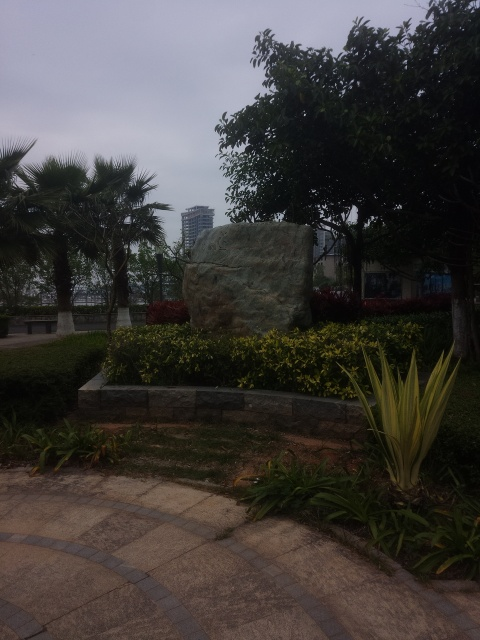What might be the significance of the large rock in this garden setting? The large rock in the garden likely serves both an aesthetic and symbolic role. Rocks like these are often used in landscaping to represent natural beauty and stability. Their placement can be strategic, possibly aiming to create a focal point within the garden that draws visitors’ attention and encourages contemplation. How can the plants around the rock enhance its appearance? The plants surrounding the rock can enhance its appearance by adding color contrast and softening the hard edges of the stone. The choice of bright yellow and red plants introduces vibrancy, while the varying heights of the shrubs add depth and create a layered look that highlights the rock as a central feature. 